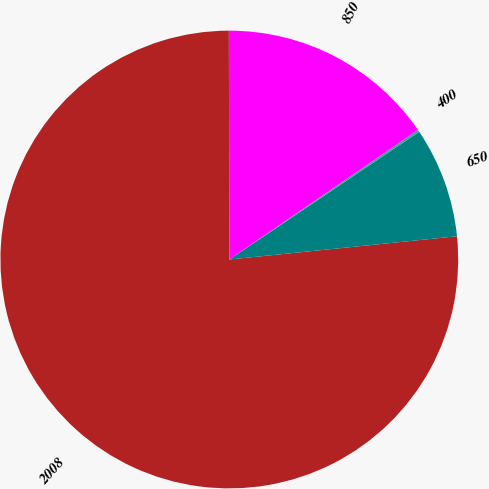Convert chart to OTSL. <chart><loc_0><loc_0><loc_500><loc_500><pie_chart><fcel>2008<fcel>650<fcel>400<fcel>850<nl><fcel>76.59%<fcel>7.8%<fcel>0.16%<fcel>15.45%<nl></chart> 